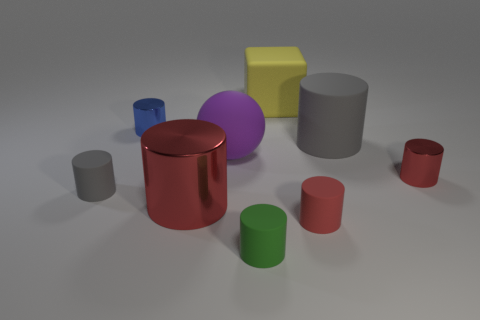What number of things are either large cyan balls or metal objects?
Provide a short and direct response. 3. There is a block that is the same size as the purple sphere; what color is it?
Make the answer very short. Yellow. Does the big red object have the same shape as the rubber thing that is on the left side of the tiny blue object?
Your answer should be compact. Yes. How many objects are big objects to the left of the purple rubber thing or matte things on the right side of the matte cube?
Offer a terse response. 3. There is a large rubber object that is to the left of the large yellow thing; what shape is it?
Offer a terse response. Sphere. There is a matte object to the left of the sphere; does it have the same shape as the big yellow rubber object?
Your answer should be very brief. No. How many things are either gray things that are on the left side of the cube or spheres?
Keep it short and to the point. 2. There is a big matte thing that is the same shape as the small gray matte object; what color is it?
Your answer should be very brief. Gray. Is there anything else that has the same color as the large rubber cylinder?
Your answer should be compact. Yes. What size is the gray thing that is to the right of the small blue metal cylinder?
Make the answer very short. Large. 